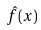Convert formula to latex. <formula><loc_0><loc_0><loc_500><loc_500>\hat { f } ( x )</formula> 